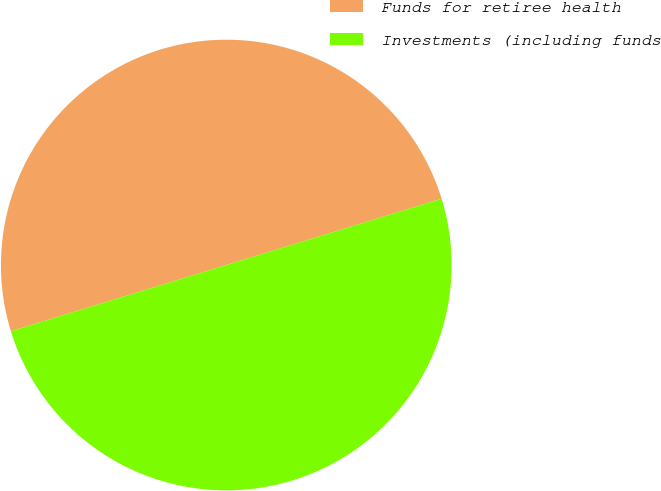Convert chart to OTSL. <chart><loc_0><loc_0><loc_500><loc_500><pie_chart><fcel>Funds for retiree health<fcel>Investments (including funds<nl><fcel>49.99%<fcel>50.01%<nl></chart> 